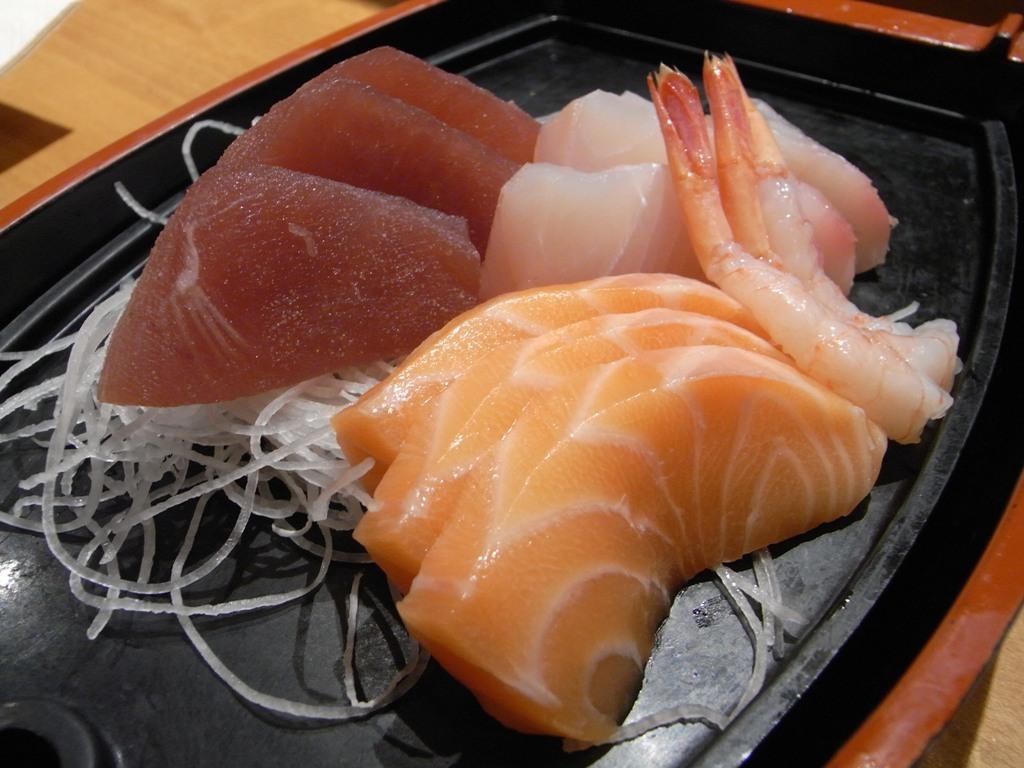In one or two sentences, can you explain what this image depicts? In this image I can see the black color plate with meat and the onion slices. The plate is on the brown color surface. 